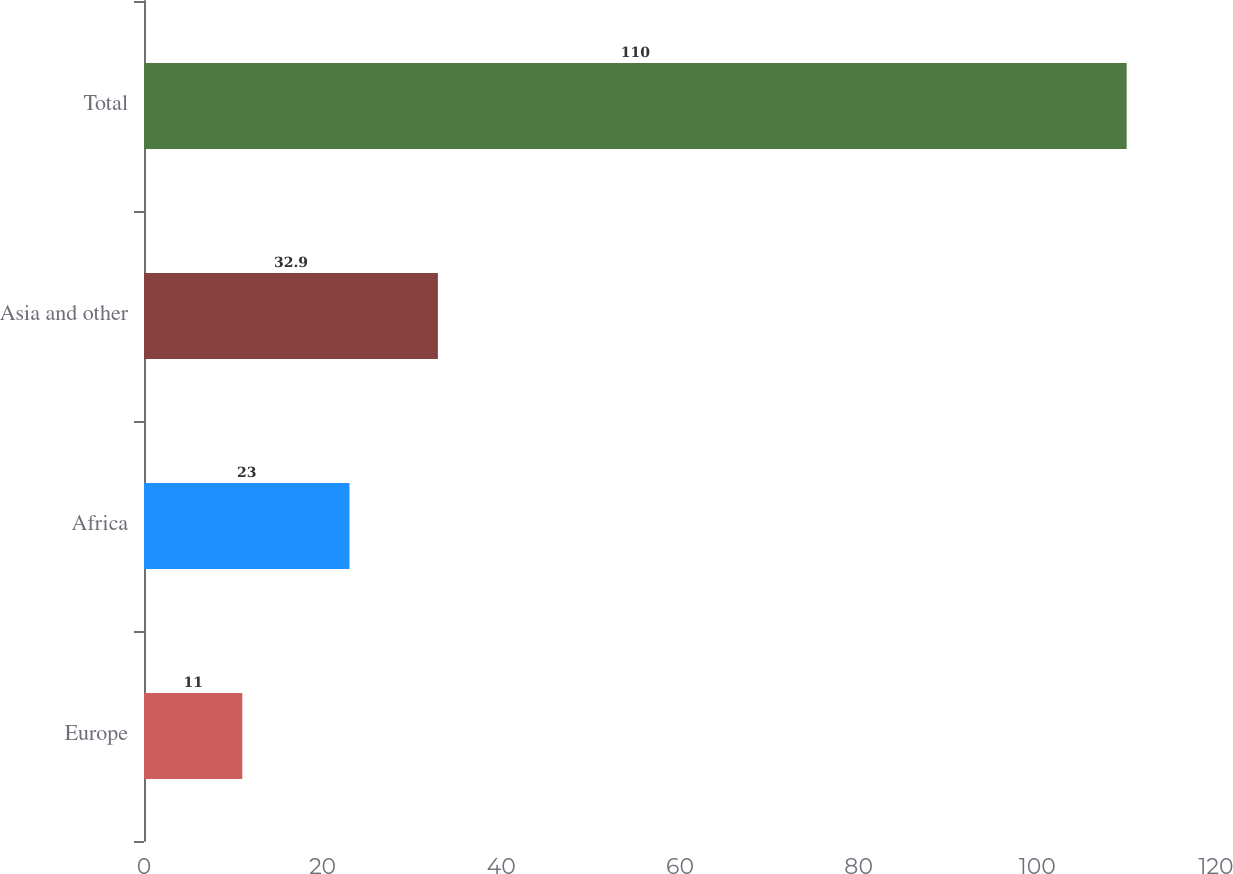<chart> <loc_0><loc_0><loc_500><loc_500><bar_chart><fcel>Europe<fcel>Africa<fcel>Asia and other<fcel>Total<nl><fcel>11<fcel>23<fcel>32.9<fcel>110<nl></chart> 